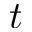Convert formula to latex. <formula><loc_0><loc_0><loc_500><loc_500>t</formula> 